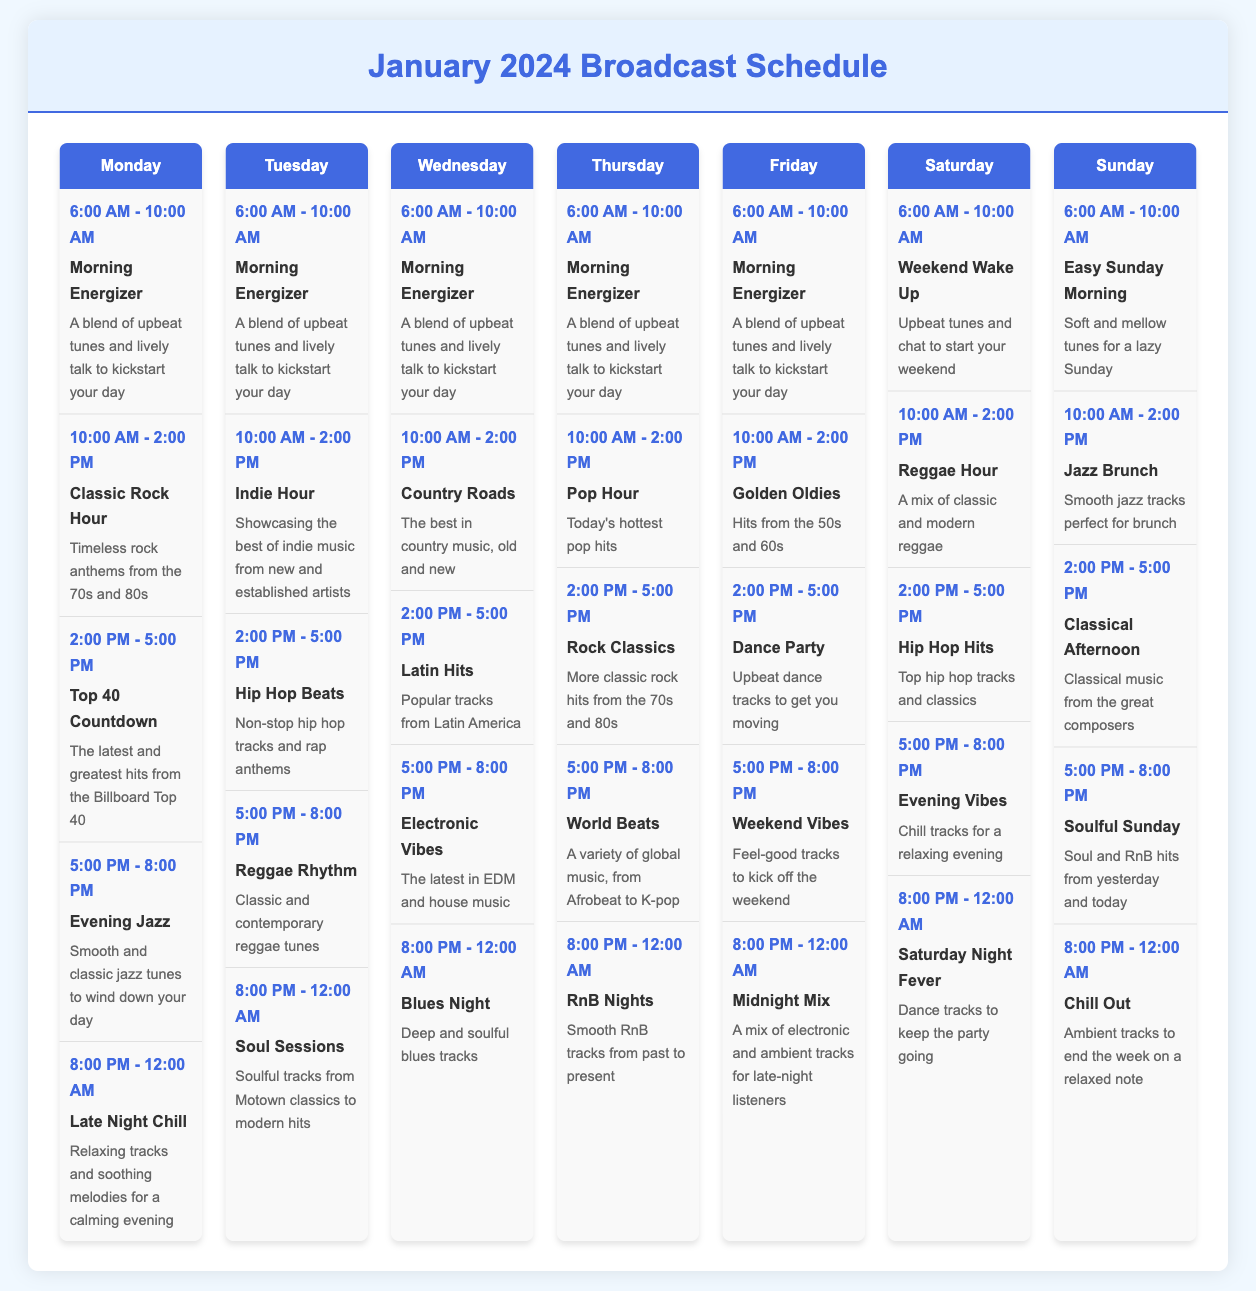What show airs from 10:00 AM to 2:00 PM on Monday? The show that airs during this time is "Classic Rock Hour."
Answer: Classic Rock Hour How many shows are scheduled on Wednesday? There are a total of five shows scheduled on Wednesday.
Answer: 5 What is the title of the show that plays from 8:00 PM to 12:00 AM on Friday? The title of the show during that time is "Midnight Mix."
Answer: Midnight Mix Which day features "Soul Sessions"? "Soul Sessions" is featured on Tuesday.
Answer: Tuesday What type of music is played during "Jazz Brunch"? "Jazz Brunch" features smooth jazz tracks.
Answer: Smooth jazz tracks How does the show scheduled from 2:00 PM to 5:00 PM on Thursday compare to its Monday counterpart? The Thursday show is "Rock Classics," while the Monday show is "Top 40 Countdown."
Answer: Rock Classics vs Top 40 Countdown What is the theme of the show airing from 6:00 AM to 10:00 AM every day? The theme is an energizing mix of tunes and talk to start the day.
Answer: Morning Energizer Which show has the longest duration on Saturday? The show "Saturday Night Fever" lasts for 4 hours, making it the longest.
Answer: Saturday Night Fever 